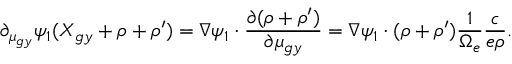Convert formula to latex. <formula><loc_0><loc_0><loc_500><loc_500>\partial _ { \mu _ { g y } } \psi _ { 1 } ( X _ { g y } + \rho + \rho ^ { \prime } ) = \nabla \psi _ { 1 } \cdot \frac { \partial ( \rho + \rho ^ { \prime } ) } { \partial \mu _ { g y } } = \nabla \psi _ { 1 } \cdot ( \rho + \rho ^ { \prime } ) \frac { 1 } { \Omega _ { e } } \frac { c } { e \rho } .</formula> 